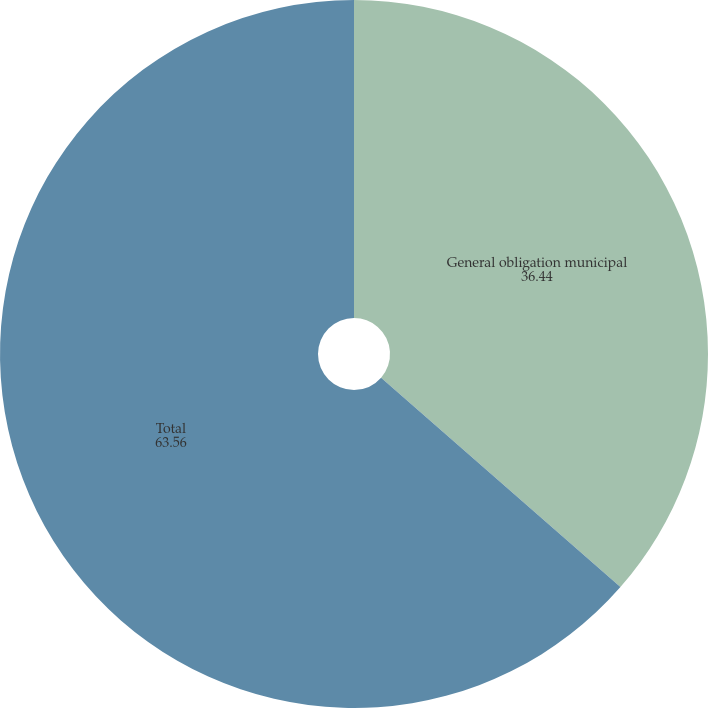Convert chart to OTSL. <chart><loc_0><loc_0><loc_500><loc_500><pie_chart><fcel>General obligation municipal<fcel>Total<nl><fcel>36.44%<fcel>63.56%<nl></chart> 